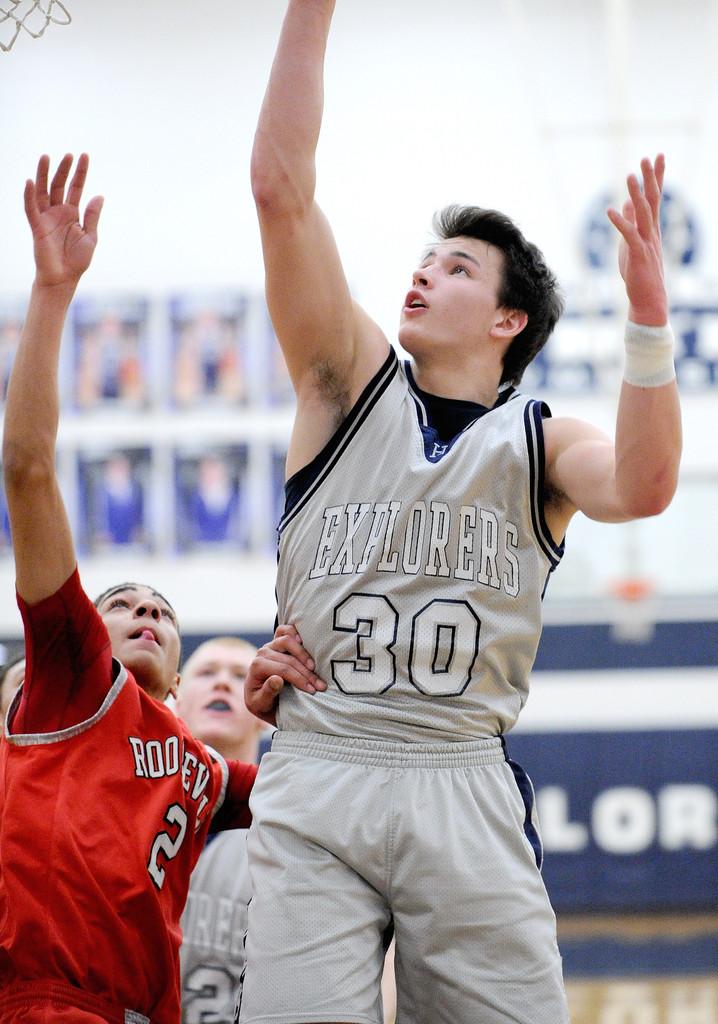What is the team name of the grey team?
Provide a succinct answer. Explorers. What number is the player on the right?
Your response must be concise. 30. 